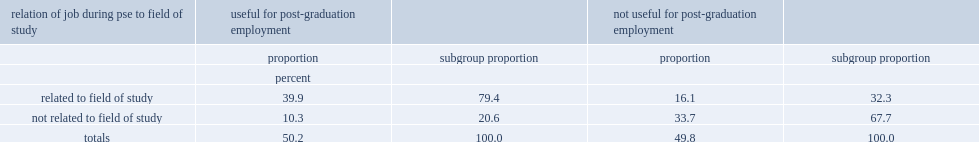What was the percentage of students that graduated between 2012 and 2016 and had a job during their post-secondary education who found this job useful for obtaining their first career job? 50.2. What was the percentage of graduates that found their job during pse useful for obtaining their first career job who had a job during their pse that was related to their field of study? 79.4. 